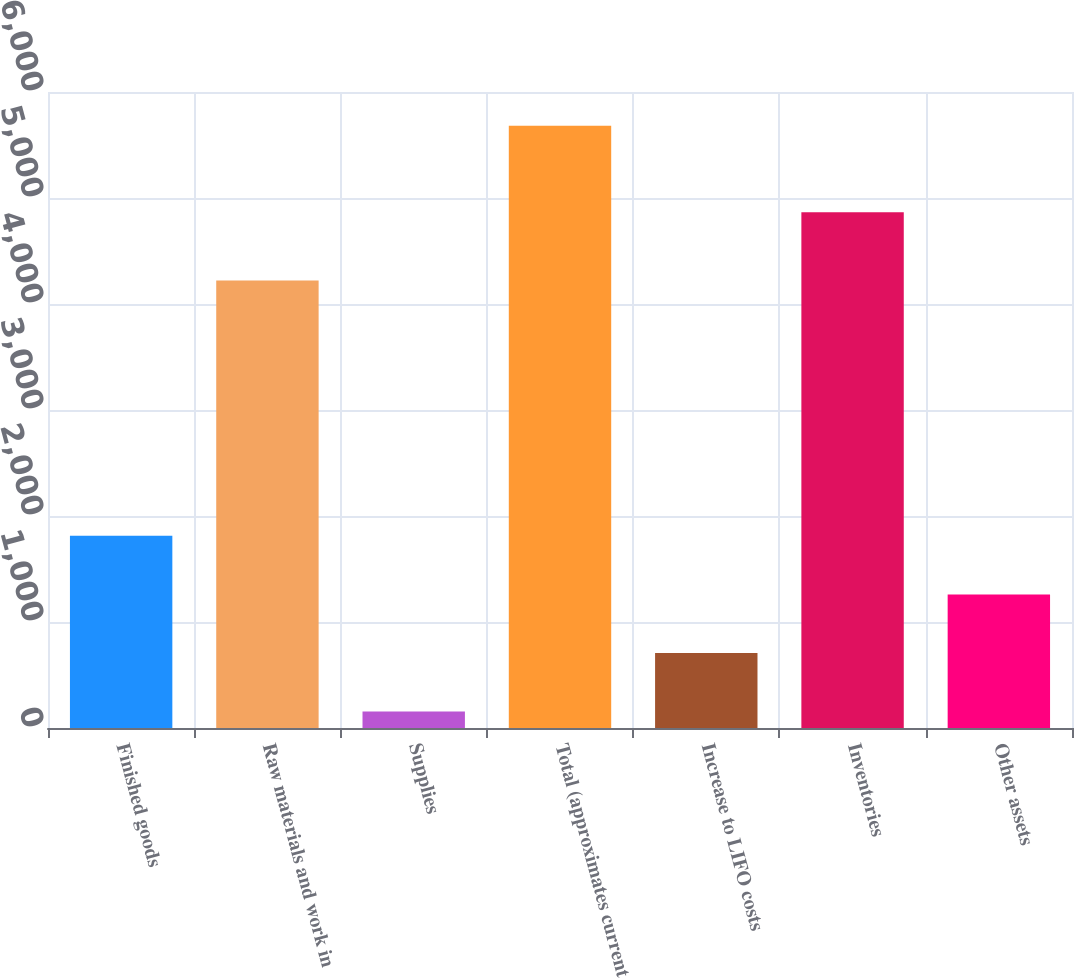<chart> <loc_0><loc_0><loc_500><loc_500><bar_chart><fcel>Finished goods<fcel>Raw materials and work in<fcel>Supplies<fcel>Total (approximates current<fcel>Increase to LIFO costs<fcel>Inventories<fcel>Other assets<nl><fcel>1812.8<fcel>4222<fcel>155<fcel>5681<fcel>707.6<fcel>4866<fcel>1260.2<nl></chart> 